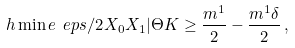<formula> <loc_0><loc_0><loc_500><loc_500>\ h \min e { \ e p s / 2 } { X _ { 0 } X _ { 1 } | \Theta K } \geq \frac { m ^ { 1 } } { 2 } - \frac { m ^ { 1 } \delta } { 2 } \, ,</formula> 